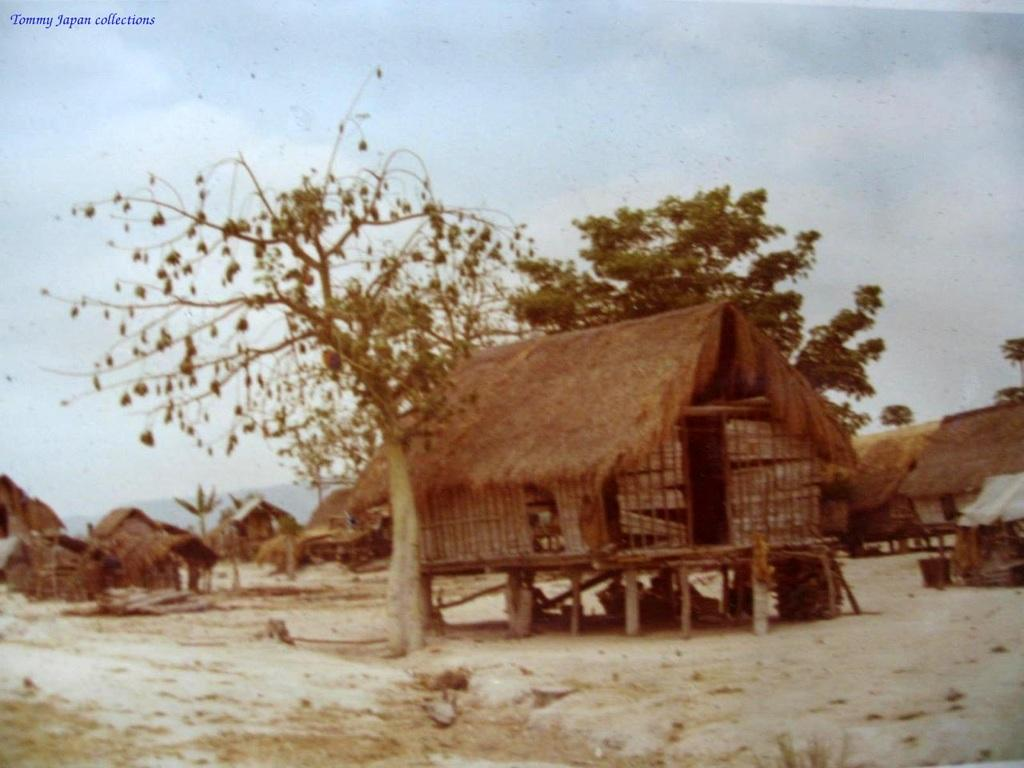What type of structures are present in the image? There are huts in the image. What other natural elements can be seen in the image? There are trees in the image. What is visible at the top of the image? The sky is visible at the top of the image. What can be observed in the sky? There are clouds in the sky. What is visible at the bottom of the image? The ground is visible at the bottom of the image. Where is the text located in the image? The text is at the top left of the image. What type of stew is being prepared in the huts in the image? There is no indication of any stew being prepared in the image; it only shows huts, trees, sky, clouds, and text. 